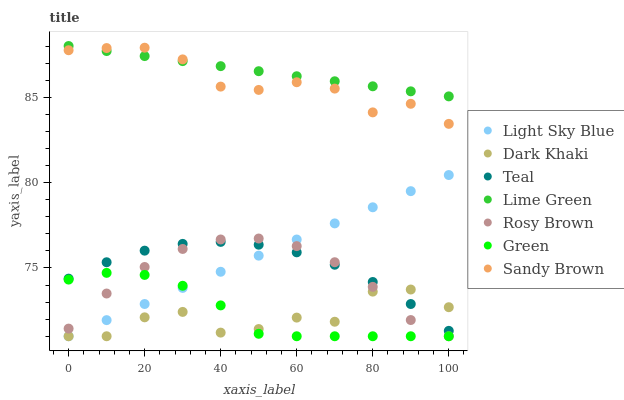Does Dark Khaki have the minimum area under the curve?
Answer yes or no. Yes. Does Lime Green have the maximum area under the curve?
Answer yes or no. Yes. Does Rosy Brown have the minimum area under the curve?
Answer yes or no. No. Does Rosy Brown have the maximum area under the curve?
Answer yes or no. No. Is Lime Green the smoothest?
Answer yes or no. Yes. Is Dark Khaki the roughest?
Answer yes or no. Yes. Is Rosy Brown the smoothest?
Answer yes or no. No. Is Rosy Brown the roughest?
Answer yes or no. No. Does Rosy Brown have the lowest value?
Answer yes or no. Yes. Does Teal have the lowest value?
Answer yes or no. No. Does Lime Green have the highest value?
Answer yes or no. Yes. Does Rosy Brown have the highest value?
Answer yes or no. No. Is Dark Khaki less than Lime Green?
Answer yes or no. Yes. Is Teal greater than Green?
Answer yes or no. Yes. Does Dark Khaki intersect Rosy Brown?
Answer yes or no. Yes. Is Dark Khaki less than Rosy Brown?
Answer yes or no. No. Is Dark Khaki greater than Rosy Brown?
Answer yes or no. No. Does Dark Khaki intersect Lime Green?
Answer yes or no. No. 